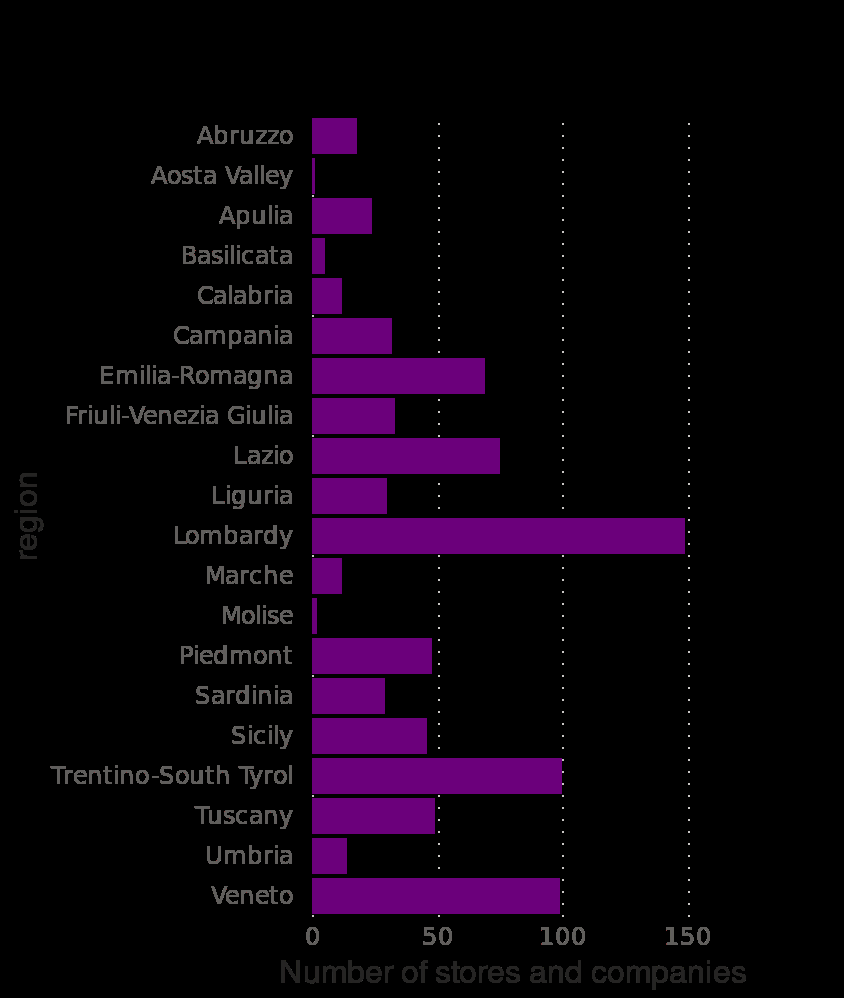<image>
What does the bar graph represent?  The bar graph represents the number of stores and companies accepting Bitcoin in Italy as of November 2019, categorized by region. When was the data collected for the bar graph?  The data for the bar graph was collected as of November 2019. 